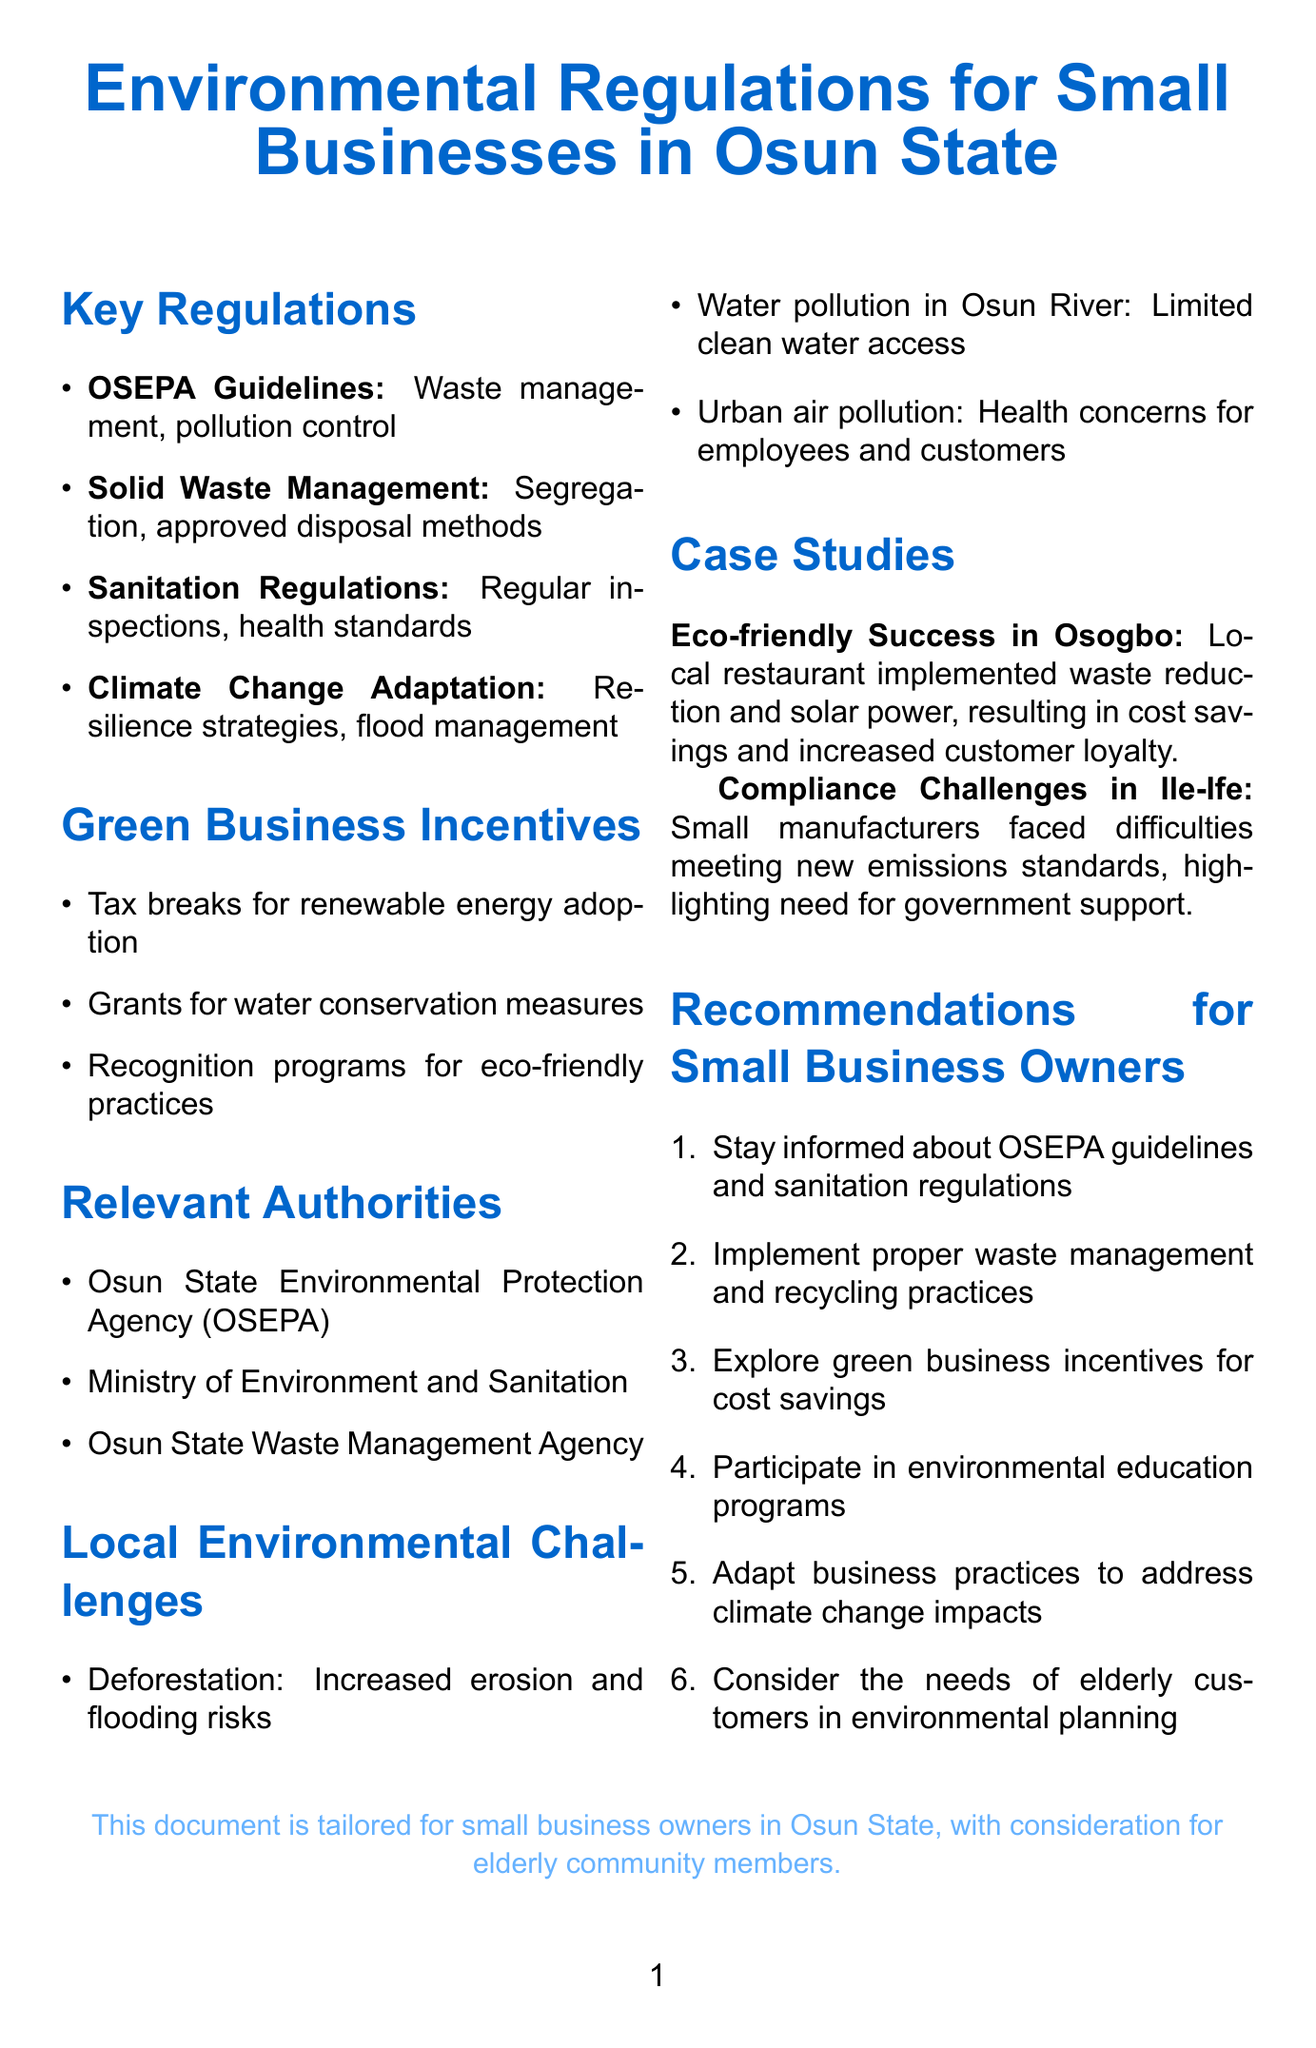What are the OSEPA guidelines about? The OSEPA guidelines concern regulations set by OSEPA affecting small businesses, specifically on waste management and pollution control.
Answer: Waste management requirements for small businesses What is one of the penalties mentioned for non-compliance? The document states that there are penalties for non-compliance with environmental regulations, although it does not specify the exact penalties.
Answer: Penalties for non-compliance Which organization primarily regulates environmental protection in Osun State? The organization responsible for environmental regulation in Osun State is mentioned in the document.
Answer: Osun State Environmental Protection Agency (OSEPA) What is required for businesses under the Solid Waste Management Policy? One key point of the Solid Waste Management policy involves operational requirements that can typically be summarized by their need to manage waste properly.
Answer: Mandatory waste segregation for businesses What should small business owners consider for elderly customers? The document emphasizes the importance of specific considerations for certain demographics while planning business environmental practices.
Answer: Consider the needs of elderly customers in environmental planning What is a financial incentive offered for green practices? The incentives offered for adopting certain practices are summarized in the document as one of the supportive measures for businesses.
Answer: Tax breaks for adopting renewable energy sources How many local environmental challenges are listed? The number of local environmental challenges indicated in the document is specified, reflecting the situation in Osun State.
Answer: Three What program promotes environmental education? The document mentions programs that aim to foster understanding and knowledge about environmental matters among business owners and the public.
Answer: Environmental Education and Awareness Programs in Osun State What was a notable case study mentioned regarding a restaurant? A successful implementation in a specific local business is described, highlighting the positive outcomes it experienced after certain initiatives.
Answer: Eco-friendly Small Business Success in Osogbo 